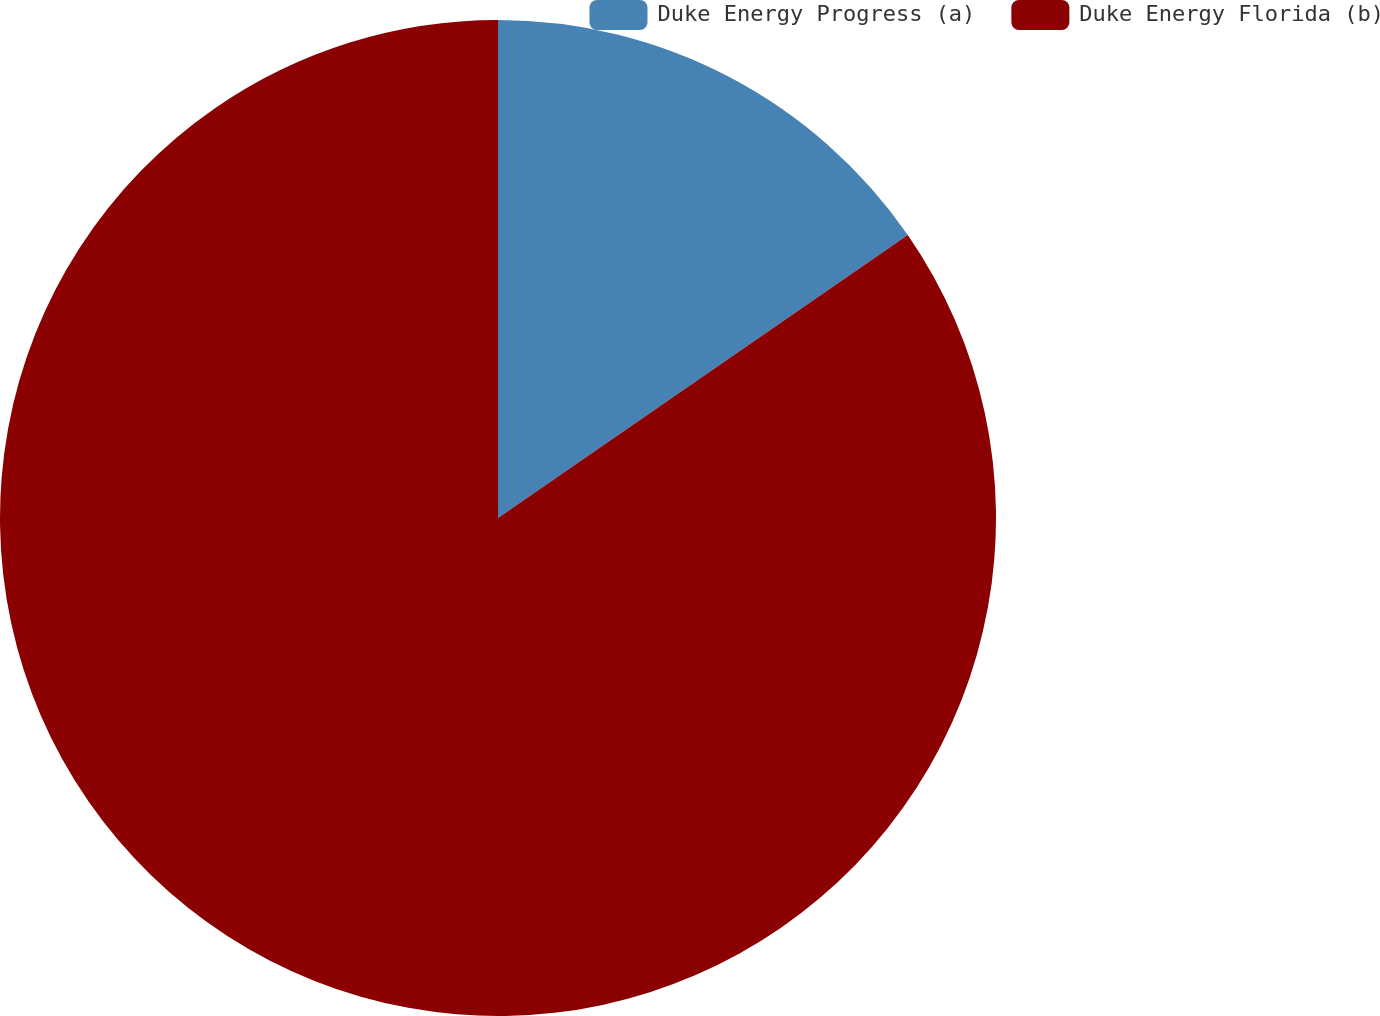<chart> <loc_0><loc_0><loc_500><loc_500><pie_chart><fcel>Duke Energy Progress (a)<fcel>Duke Energy Florida (b)<nl><fcel>15.38%<fcel>84.62%<nl></chart> 